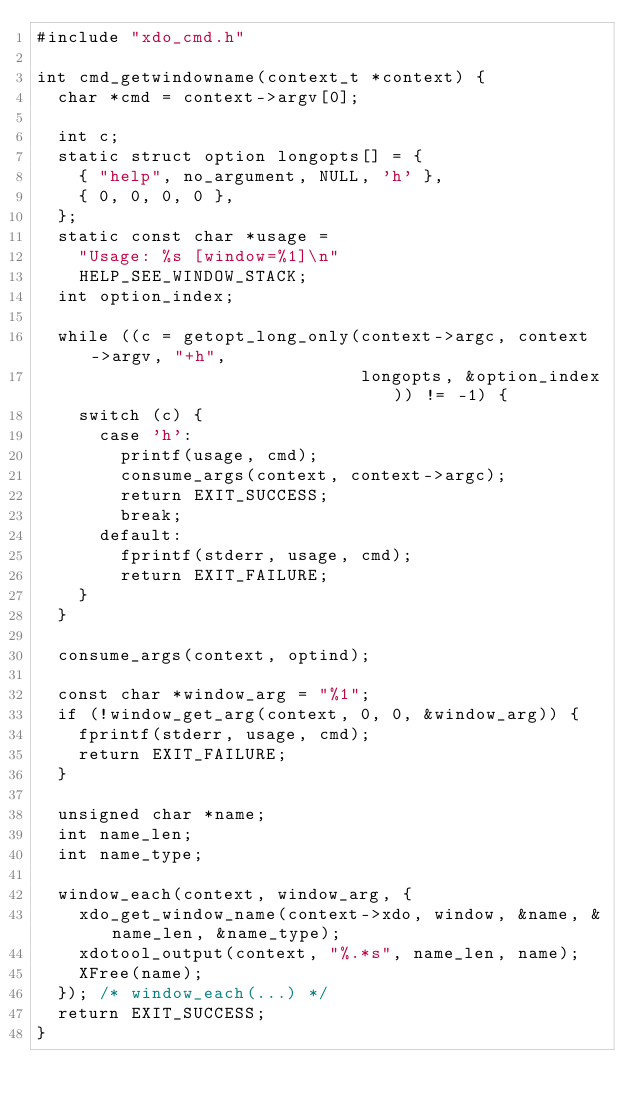Convert code to text. <code><loc_0><loc_0><loc_500><loc_500><_C_>#include "xdo_cmd.h"

int cmd_getwindowname(context_t *context) {
  char *cmd = context->argv[0];

  int c;
  static struct option longopts[] = {
    { "help", no_argument, NULL, 'h' },
    { 0, 0, 0, 0 },
  };
  static const char *usage = 
    "Usage: %s [window=%1]\n"
    HELP_SEE_WINDOW_STACK;
  int option_index;

  while ((c = getopt_long_only(context->argc, context->argv, "+h",
                               longopts, &option_index)) != -1) {
    switch (c) {
      case 'h':
        printf(usage, cmd);
        consume_args(context, context->argc);
        return EXIT_SUCCESS;
        break;
      default:
        fprintf(stderr, usage, cmd);
        return EXIT_FAILURE;
    }
  }

  consume_args(context, optind);

  const char *window_arg = "%1";
  if (!window_get_arg(context, 0, 0, &window_arg)) {
    fprintf(stderr, usage, cmd);
    return EXIT_FAILURE;
  }

  unsigned char *name;
  int name_len;
  int name_type;

  window_each(context, window_arg, {
    xdo_get_window_name(context->xdo, window, &name, &name_len, &name_type);
    xdotool_output(context, "%.*s", name_len, name);
    XFree(name);
  }); /* window_each(...) */
  return EXIT_SUCCESS;
}

</code> 